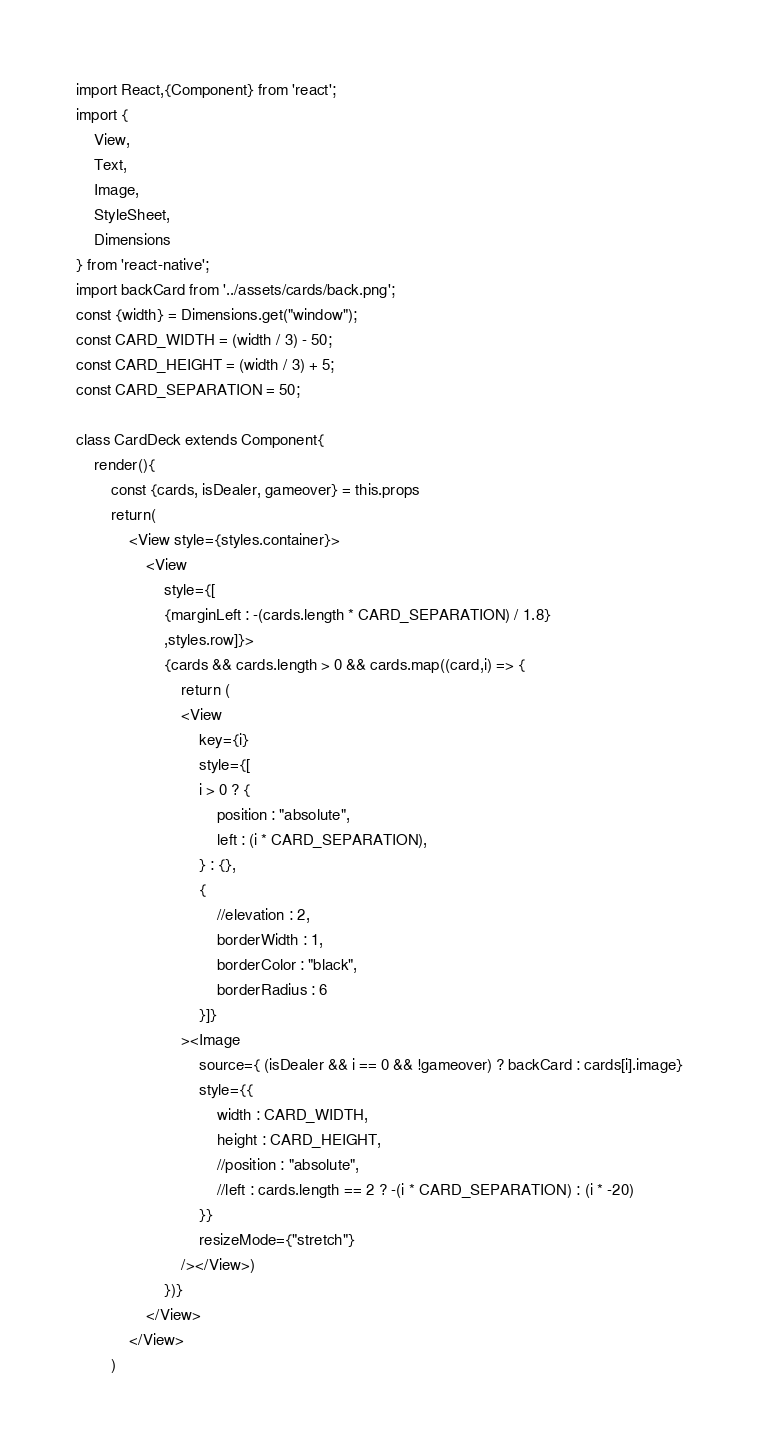<code> <loc_0><loc_0><loc_500><loc_500><_JavaScript_>import React,{Component} from 'react';
import {
    View,
    Text,
    Image,
    StyleSheet,
    Dimensions
} from 'react-native';
import backCard from '../assets/cards/back.png';
const {width} = Dimensions.get("window");
const CARD_WIDTH = (width / 3) - 50;
const CARD_HEIGHT = (width / 3) + 5;
const CARD_SEPARATION = 50;

class CardDeck extends Component{
    render(){
        const {cards, isDealer, gameover} = this.props
        return(
            <View style={styles.container}>
                <View 
                    style={[
                    {marginLeft : -(cards.length * CARD_SEPARATION) / 1.8}
                    ,styles.row]}>
                    {cards && cards.length > 0 && cards.map((card,i) => {
                        return (
                        <View
                            key={i}
                            style={[
                            i > 0 ? {
                                position : "absolute",
                                left : (i * CARD_SEPARATION),
                            } : {},
                            {
                                //elevation : 2,
                                borderWidth : 1,
                                borderColor : "black",
                                borderRadius : 6
                            }]}
                        ><Image 
                            source={ (isDealer && i == 0 && !gameover) ? backCard : cards[i].image}
                            style={{
                                width : CARD_WIDTH,
                                height : CARD_HEIGHT,
                                //position : "absolute",
                                //left : cards.length == 2 ? -(i * CARD_SEPARATION) : (i * -20)
                            }}
                            resizeMode={"stretch"}
                        /></View>)
                    })}
                </View>
            </View>
        )</code> 